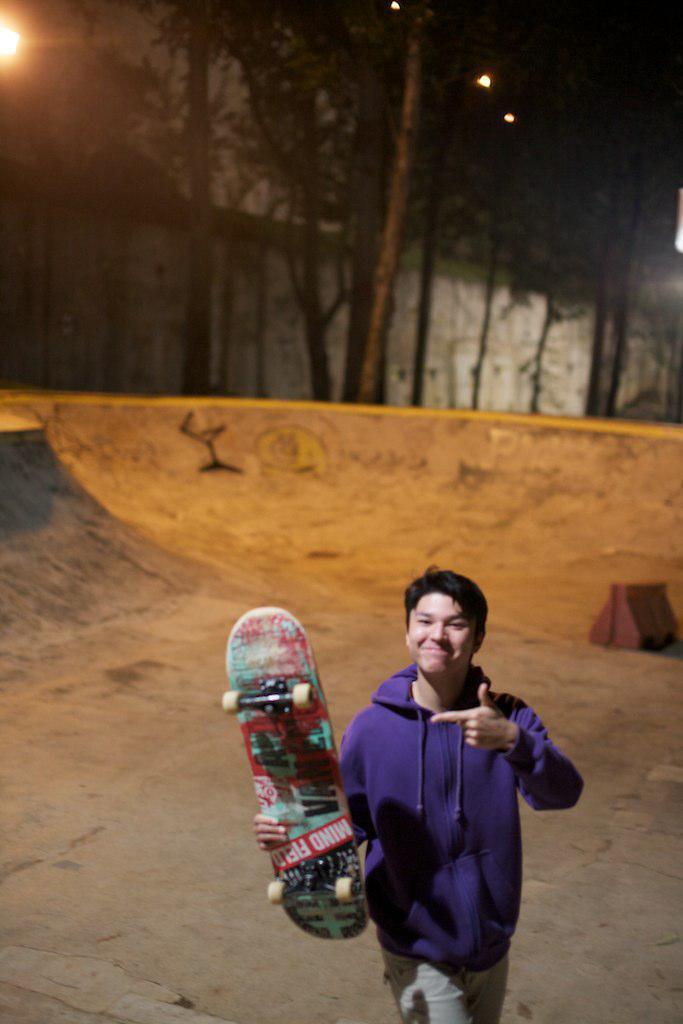How would you summarize this image in a sentence or two? In this image in the center there is one person who is holding a skateboard and walking, in the background there is slope and some houses, trees and lights. 